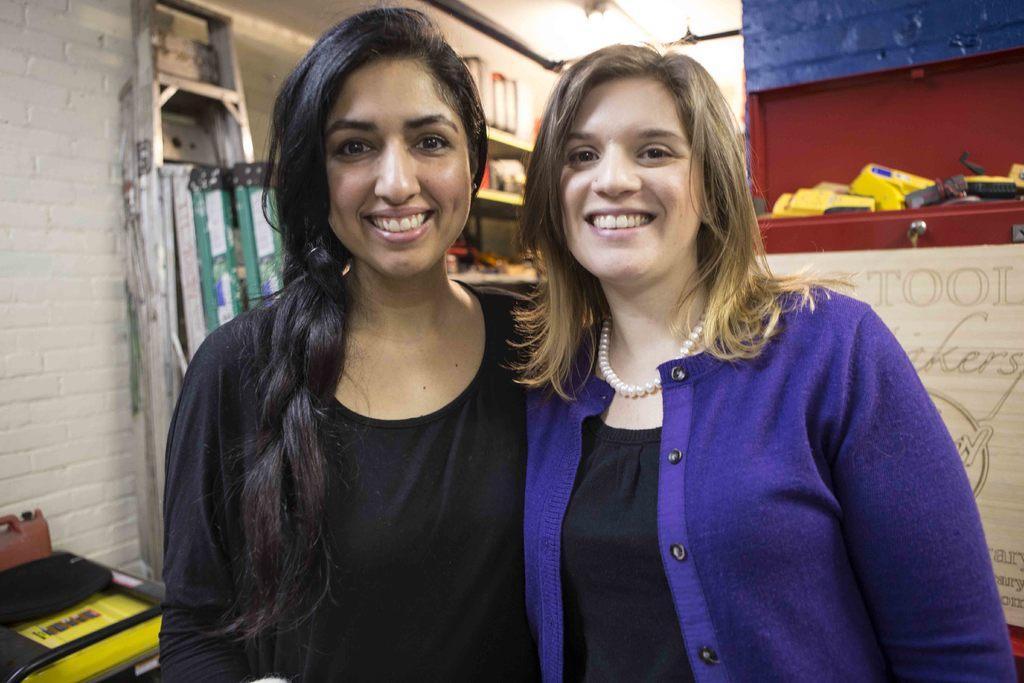Please provide a concise description of this image. In this picture we can see two women smiling and in the background we can see ladders, wall and some objects. 